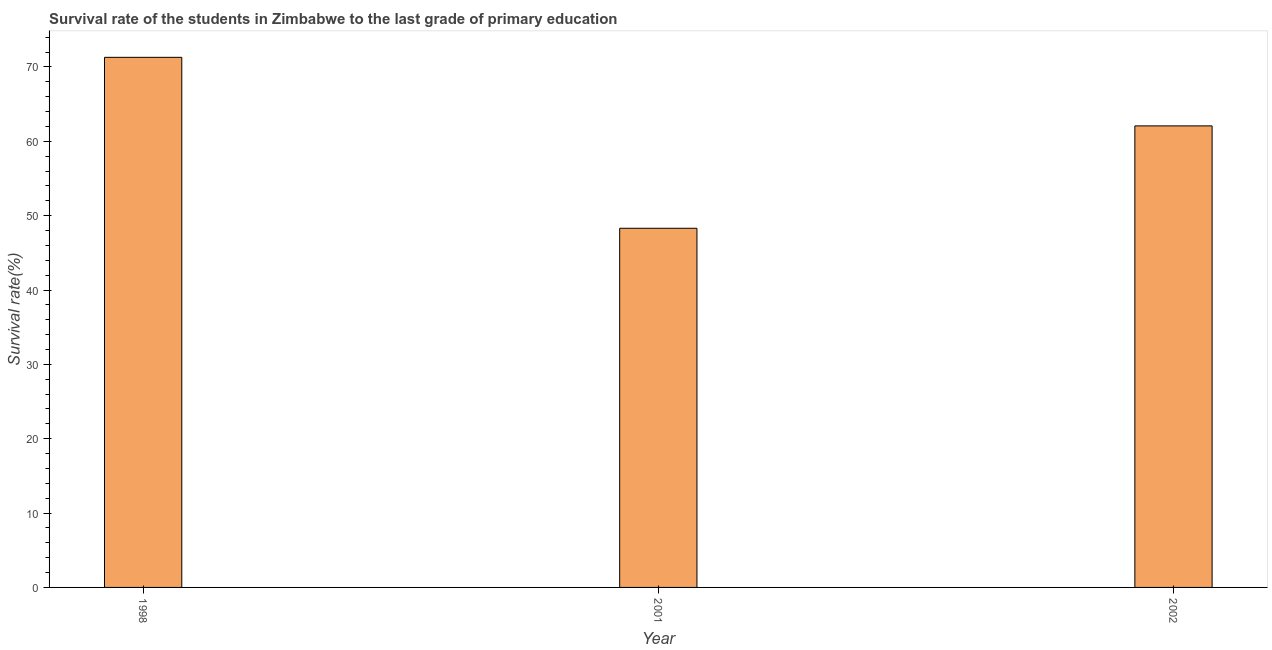What is the title of the graph?
Give a very brief answer. Survival rate of the students in Zimbabwe to the last grade of primary education. What is the label or title of the Y-axis?
Offer a terse response. Survival rate(%). What is the survival rate in primary education in 2002?
Your response must be concise. 62.07. Across all years, what is the maximum survival rate in primary education?
Keep it short and to the point. 71.29. Across all years, what is the minimum survival rate in primary education?
Offer a very short reply. 48.3. In which year was the survival rate in primary education maximum?
Make the answer very short. 1998. What is the sum of the survival rate in primary education?
Your answer should be very brief. 181.67. What is the difference between the survival rate in primary education in 2001 and 2002?
Offer a very short reply. -13.77. What is the average survival rate in primary education per year?
Your answer should be very brief. 60.55. What is the median survival rate in primary education?
Ensure brevity in your answer.  62.07. In how many years, is the survival rate in primary education greater than 20 %?
Provide a short and direct response. 3. Do a majority of the years between 1998 and 2001 (inclusive) have survival rate in primary education greater than 62 %?
Give a very brief answer. No. What is the ratio of the survival rate in primary education in 1998 to that in 2002?
Your response must be concise. 1.15. Is the survival rate in primary education in 2001 less than that in 2002?
Make the answer very short. Yes. What is the difference between the highest and the second highest survival rate in primary education?
Provide a succinct answer. 9.22. What is the difference between the highest and the lowest survival rate in primary education?
Offer a very short reply. 22.99. Are the values on the major ticks of Y-axis written in scientific E-notation?
Provide a succinct answer. No. What is the Survival rate(%) of 1998?
Your answer should be compact. 71.29. What is the Survival rate(%) of 2001?
Offer a terse response. 48.3. What is the Survival rate(%) in 2002?
Provide a short and direct response. 62.07. What is the difference between the Survival rate(%) in 1998 and 2001?
Offer a very short reply. 22.99. What is the difference between the Survival rate(%) in 1998 and 2002?
Your answer should be compact. 9.22. What is the difference between the Survival rate(%) in 2001 and 2002?
Ensure brevity in your answer.  -13.77. What is the ratio of the Survival rate(%) in 1998 to that in 2001?
Your answer should be very brief. 1.48. What is the ratio of the Survival rate(%) in 1998 to that in 2002?
Provide a succinct answer. 1.15. What is the ratio of the Survival rate(%) in 2001 to that in 2002?
Your answer should be very brief. 0.78. 